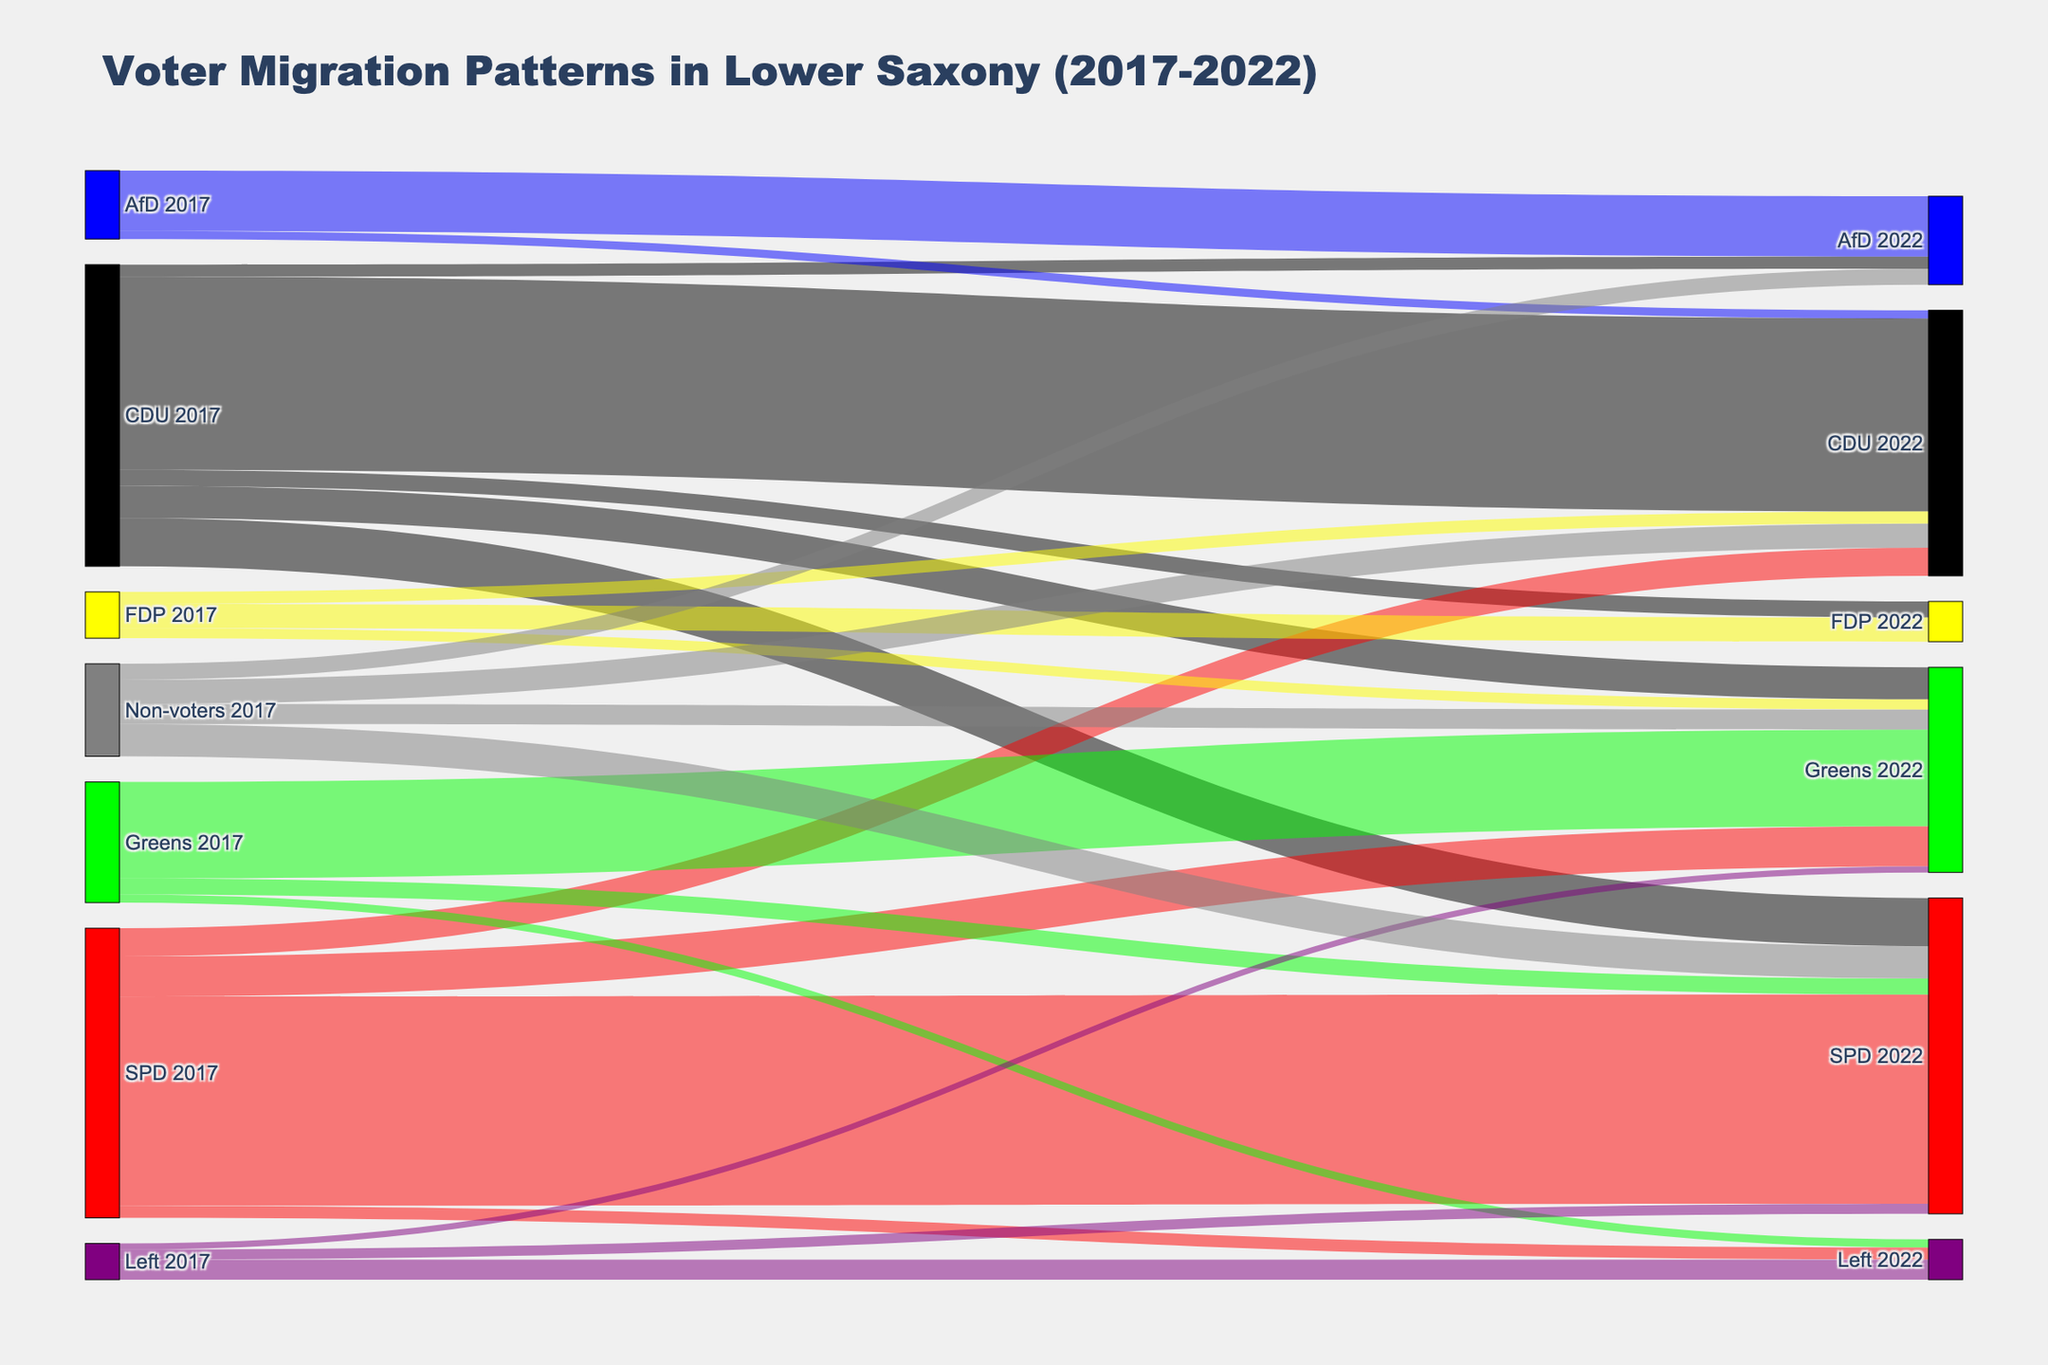What is the title of the Sankey diagram? The title is typically displayed prominently at the top of the figure and serves as an overview of what the figure represents. In this case, it explains that the Sankey diagram is about voter migration patterns in Lower Saxony over several years.
Answer: Voter Migration Patterns in Lower Saxony (2017-2022) Which political party retained the most voters from 2017 to 2022? To determine this, look for the link with the same source and target and the highest value. Each party's retained voters are shown by flows from the same party in 2017 to 2022.
Answer: SPD How many voters migrated from CDU in 2017 to Greens in 2022? Locate the flow from CDU 2017 to Greens 2022 in the Sankey diagram, and find the value associated with this flow.
Answer: 80,000 Which party received the most voters from non-voters in 2017? Identify all the flows originating from "Non-voters 2017" and compare their target values to see which party received the highest number of new voters from non-voters.
Answer: SPD How many total voters did AfD have in 2022 from 2017? Calculate the total value by summing up all the flows that end at AfD 2022. This includes voters retained from 2017 and newcomers from other parties.
Answer: 190,000 Compare the number of voters who switched from SPD to CDU and from CDU to SPD from 2017 to 2022. Which switch had a higher number of voters? Look for flows between SPD 2017 to CDU 2022 and CDU 2017 to SPD 2022, then compare their values.
Answer: More voters switched from CDU to SPD Which party had the lowest voter retention from 2017 to 2022? Calculate the retention for each party by finding the self-loop values (e.g., CDU 2017 to CDU 2022) and compare them to identify the lowest retention value.
Answer: Left How many voters did the Left lose to the SPD and Greens combined from 2017 to 2022? Sum the values of flows from Left 2017 to SPD 2022 and from Left 2017 to Greens 2022 to find the total number of lost voters.
Answer: 40,000 What percentage of CDU voters from 2017 remained with CDU in 2022? Calculate the percentage by dividing the number of voters who remained with CDU by the total number of voters CDU had in 2017, then multiply by 100.
Answer: 65.8% Which party gained voters from three different sources? Find the party that has incoming flows from at least three different source nodes (parties or non-voters) to see which party received a diverse influx of voters.
Answer: Greens 